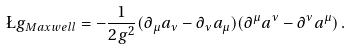Convert formula to latex. <formula><loc_0><loc_0><loc_500><loc_500>\L g _ { M a x w e l l } = - \frac { 1 } { 2 g ^ { 2 } } ( \partial _ { \mu } a _ { \nu } - \partial _ { \nu } a _ { \mu } ) ( \partial ^ { \mu } a ^ { \nu } - \partial ^ { \nu } a ^ { \mu } ) \, .</formula> 